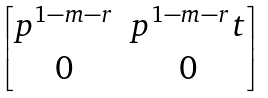<formula> <loc_0><loc_0><loc_500><loc_500>\begin{bmatrix} p ^ { 1 - m - r } & p ^ { 1 - m - r } t \\ 0 & 0 \end{bmatrix}</formula> 